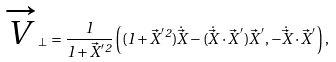<formula> <loc_0><loc_0><loc_500><loc_500>\overrightarrow { V } _ { \perp } = \frac { 1 } { 1 + \vec { X } ^ { ^ { \prime } 2 } } \left ( ( 1 + \vec { X } ^ { ^ { \prime } 2 } ) \dot { \vec { X } } - ( \dot { \vec { X } } \cdot \vec { X } ^ { ^ { \prime } } ) \vec { X } ^ { ^ { \prime } } , - \dot { \vec { X } } \cdot \vec { X } ^ { ^ { \prime } } \right ) ,</formula> 